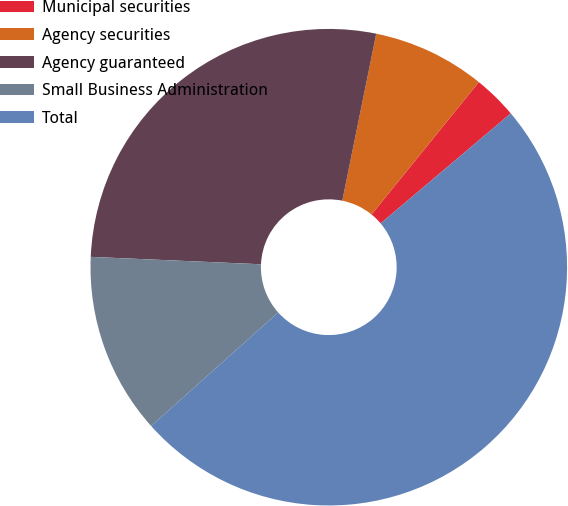Convert chart to OTSL. <chart><loc_0><loc_0><loc_500><loc_500><pie_chart><fcel>Municipal securities<fcel>Agency securities<fcel>Agency guaranteed<fcel>Small Business Administration<fcel>Total<nl><fcel>2.99%<fcel>7.65%<fcel>27.5%<fcel>12.3%<fcel>49.56%<nl></chart> 